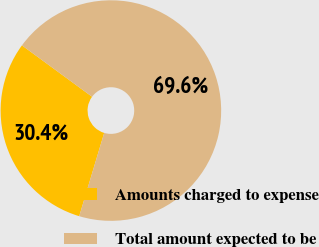<chart> <loc_0><loc_0><loc_500><loc_500><pie_chart><fcel>Amounts charged to expense<fcel>Total amount expected to be<nl><fcel>30.43%<fcel>69.57%<nl></chart> 